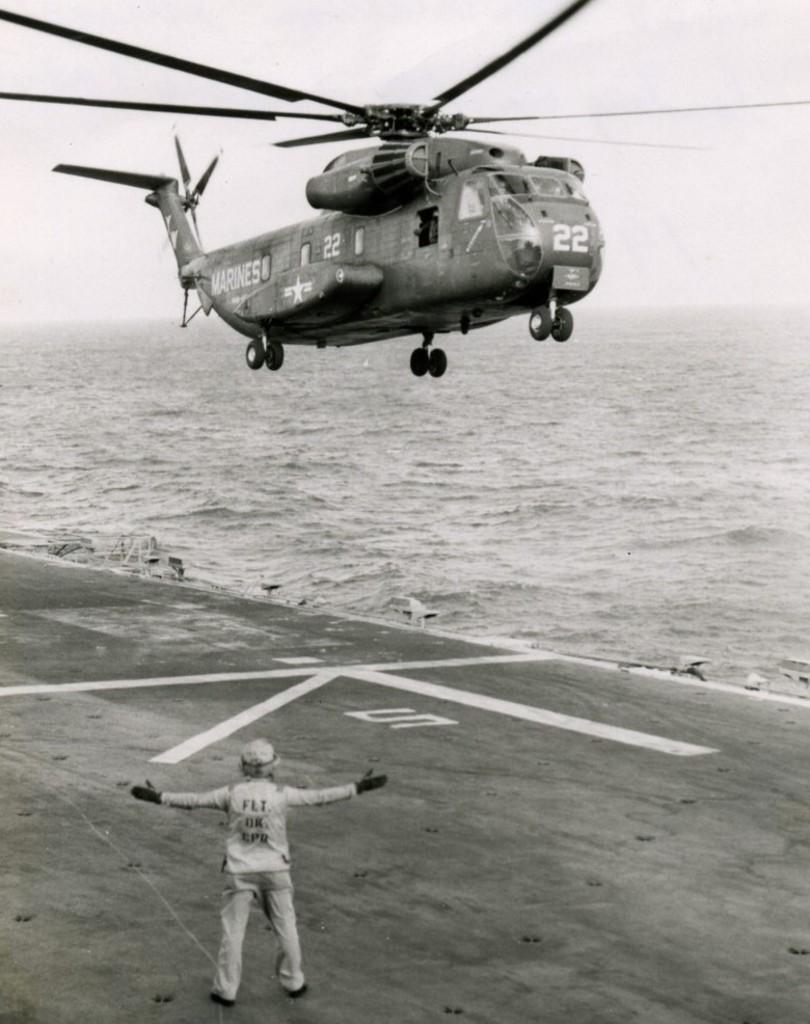Please provide a concise description of this image. This is a black and white image. In the center of the image we can see a helicopter is flying. In the background of the image we can see the water. At the bottom of the image we can see the road and a man is standing and wearing a dress, cap, gloves. At the top of the image we can see the sky. 